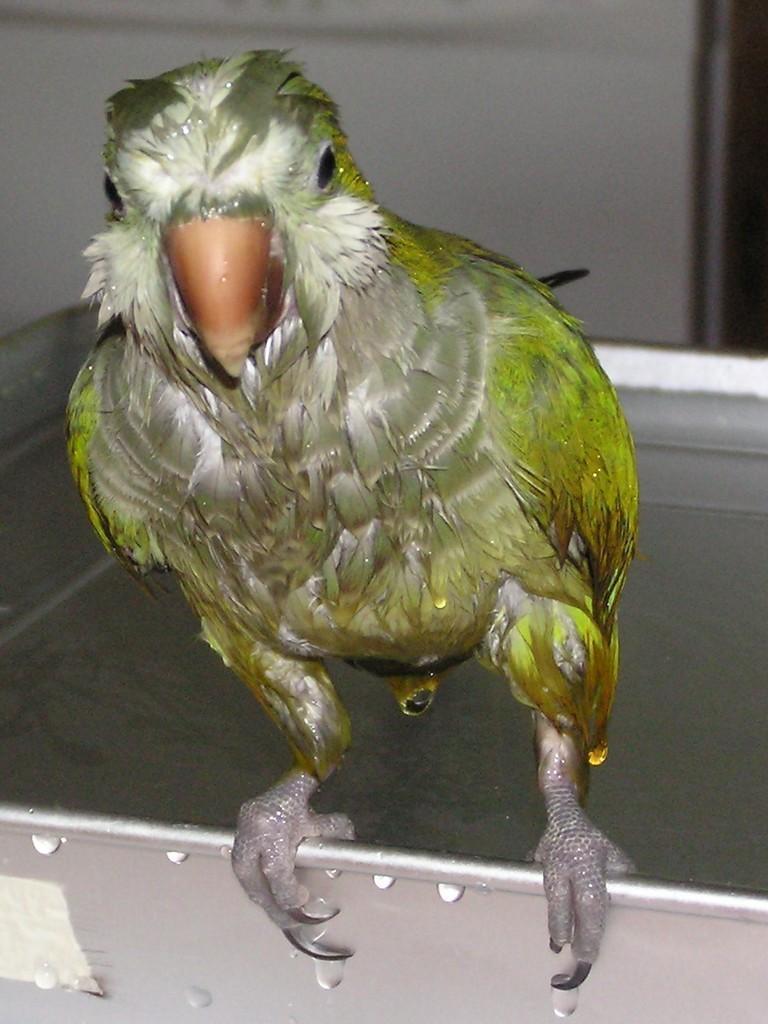In one or two sentences, can you explain what this image depicts? This picture seems to be clicked inside the room. In the foreground we can see a bird seems to be the parrot standing on an object and we can see the wall and some other items. 